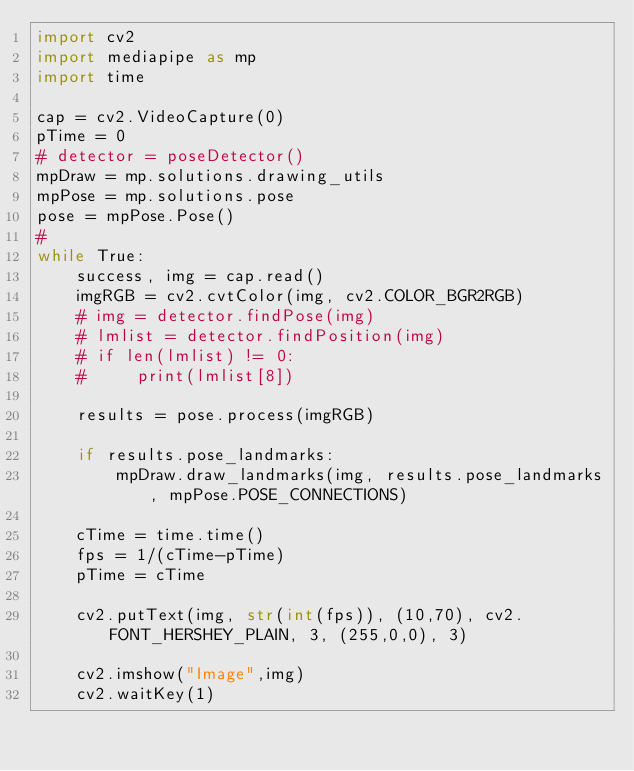Convert code to text. <code><loc_0><loc_0><loc_500><loc_500><_Python_>import cv2
import mediapipe as mp
import time

cap = cv2.VideoCapture(0)
pTime = 0
# detector = poseDetector()
mpDraw = mp.solutions.drawing_utils
mpPose = mp.solutions.pose
pose = mpPose.Pose()
#     
while True:
    success, img = cap.read()
    imgRGB = cv2.cvtColor(img, cv2.COLOR_BGR2RGB)
    # img = detector.findPose(img)
    # lmlist = detector.findPosition(img)
    # if len(lmlist) != 0:
    #     print(lmlist[8])

    results = pose.process(imgRGB)

    if results.pose_landmarks:
        mpDraw.draw_landmarks(img, results.pose_landmarks, mpPose.POSE_CONNECTIONS)

    cTime = time.time()
    fps = 1/(cTime-pTime)
    pTime = cTime

    cv2.putText(img, str(int(fps)), (10,70), cv2.FONT_HERSHEY_PLAIN, 3, (255,0,0), 3)

    cv2.imshow("Image",img)
    cv2.waitKey(1)</code> 